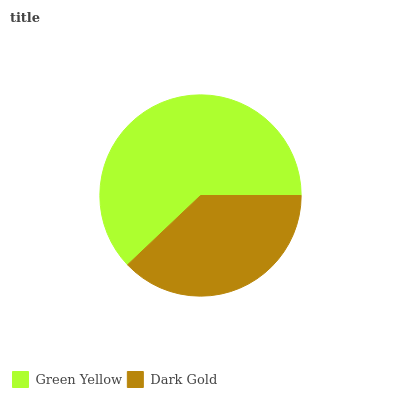Is Dark Gold the minimum?
Answer yes or no. Yes. Is Green Yellow the maximum?
Answer yes or no. Yes. Is Dark Gold the maximum?
Answer yes or no. No. Is Green Yellow greater than Dark Gold?
Answer yes or no. Yes. Is Dark Gold less than Green Yellow?
Answer yes or no. Yes. Is Dark Gold greater than Green Yellow?
Answer yes or no. No. Is Green Yellow less than Dark Gold?
Answer yes or no. No. Is Green Yellow the high median?
Answer yes or no. Yes. Is Dark Gold the low median?
Answer yes or no. Yes. Is Dark Gold the high median?
Answer yes or no. No. Is Green Yellow the low median?
Answer yes or no. No. 